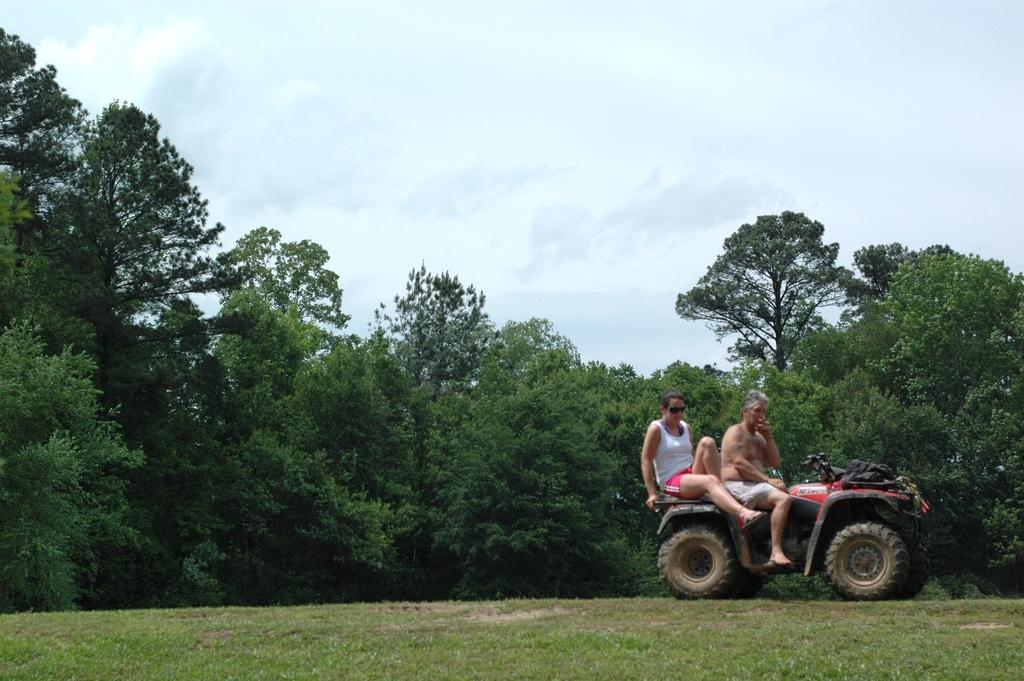What is happening in the foreground of the image? There are people on a vehicle in the foreground of the image. What can be seen in the background of the image? There are trees and the sky visible in the background of the image. How many apples are hanging from the trees in the image? There is no mention of apples in the image, so it is impossible to determine how many apples might be hanging from the trees. 